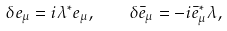Convert formula to latex. <formula><loc_0><loc_0><loc_500><loc_500>\delta e _ { \mu } = i \lambda ^ { * } e _ { \mu } , \quad \delta \bar { e } _ { \mu } = - i \bar { e } _ { \mu } ^ { * } \lambda ,</formula> 